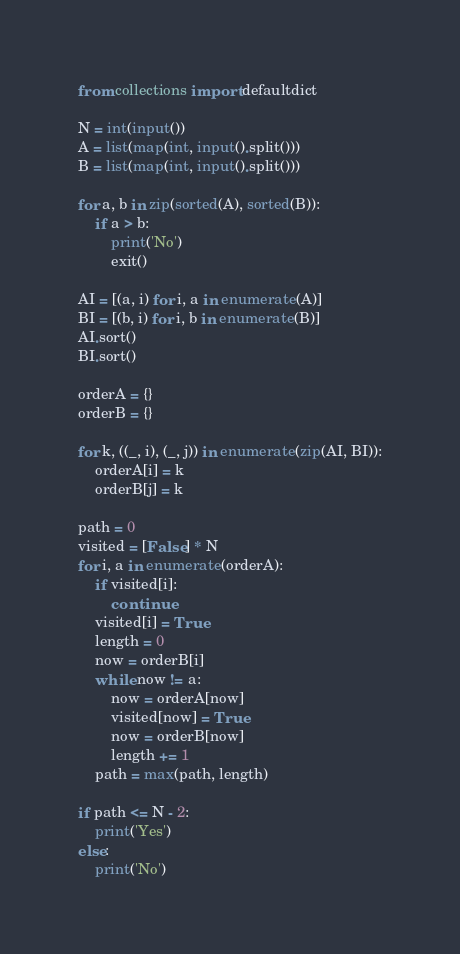Convert code to text. <code><loc_0><loc_0><loc_500><loc_500><_Python_>from collections import defaultdict

N = int(input())
A = list(map(int, input().split()))
B = list(map(int, input().split()))

for a, b in zip(sorted(A), sorted(B)):
    if a > b:
        print('No')
        exit()

AI = [(a, i) for i, a in enumerate(A)]
BI = [(b, i) for i, b in enumerate(B)]
AI.sort()
BI.sort()

orderA = {}
orderB = {}

for k, ((_, i), (_, j)) in enumerate(zip(AI, BI)):
    orderA[i] = k
    orderB[j] = k

path = 0
visited = [False] * N
for i, a in enumerate(orderA):
    if visited[i]:
        continue
    visited[i] = True
    length = 0
    now = orderB[i]
    while now != a:
        now = orderA[now]
        visited[now] = True
        now = orderB[now]
        length += 1
    path = max(path, length)

if path <= N - 2:
    print('Yes')
else:
    print('No')</code> 